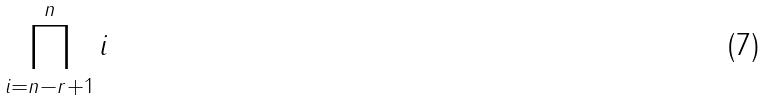<formula> <loc_0><loc_0><loc_500><loc_500>\prod _ { i = n - r + 1 } ^ { n } i</formula> 